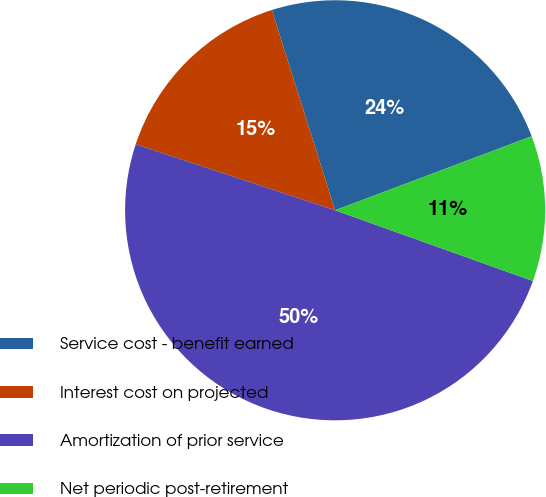Convert chart. <chart><loc_0><loc_0><loc_500><loc_500><pie_chart><fcel>Service cost - benefit earned<fcel>Interest cost on projected<fcel>Amortization of prior service<fcel>Net periodic post-retirement<nl><fcel>24.14%<fcel>15.04%<fcel>49.62%<fcel>11.2%<nl></chart> 